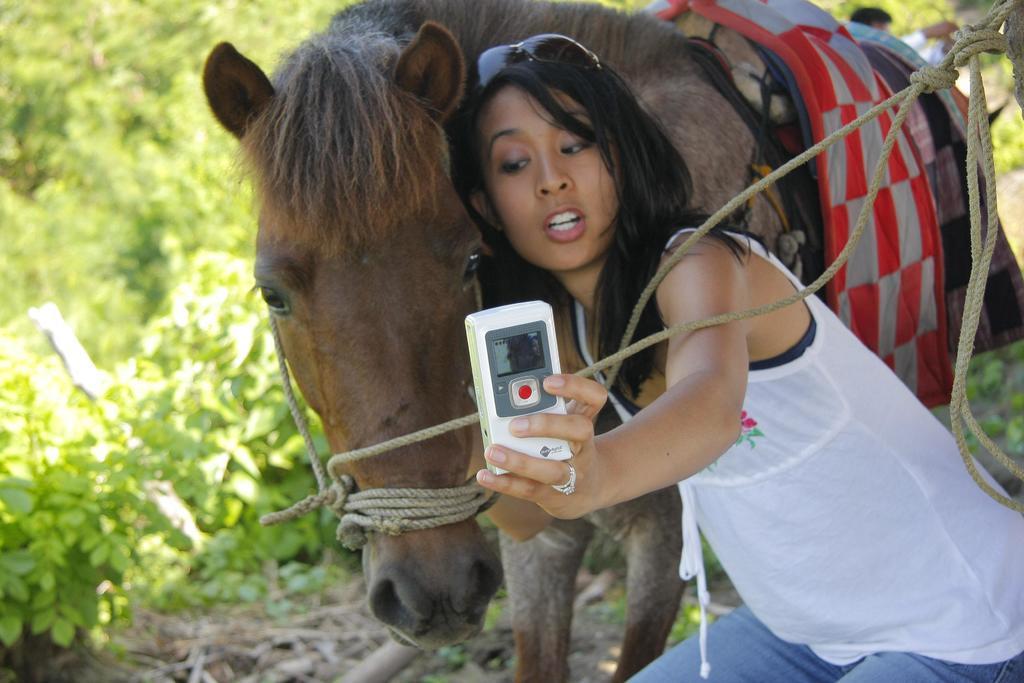In one or two sentences, can you explain what this image depicts? in this image the woman she is taking the selfie with the horse and she is wearing the white top and blue jeans and she is wearing the glass and the background is very greenery. 